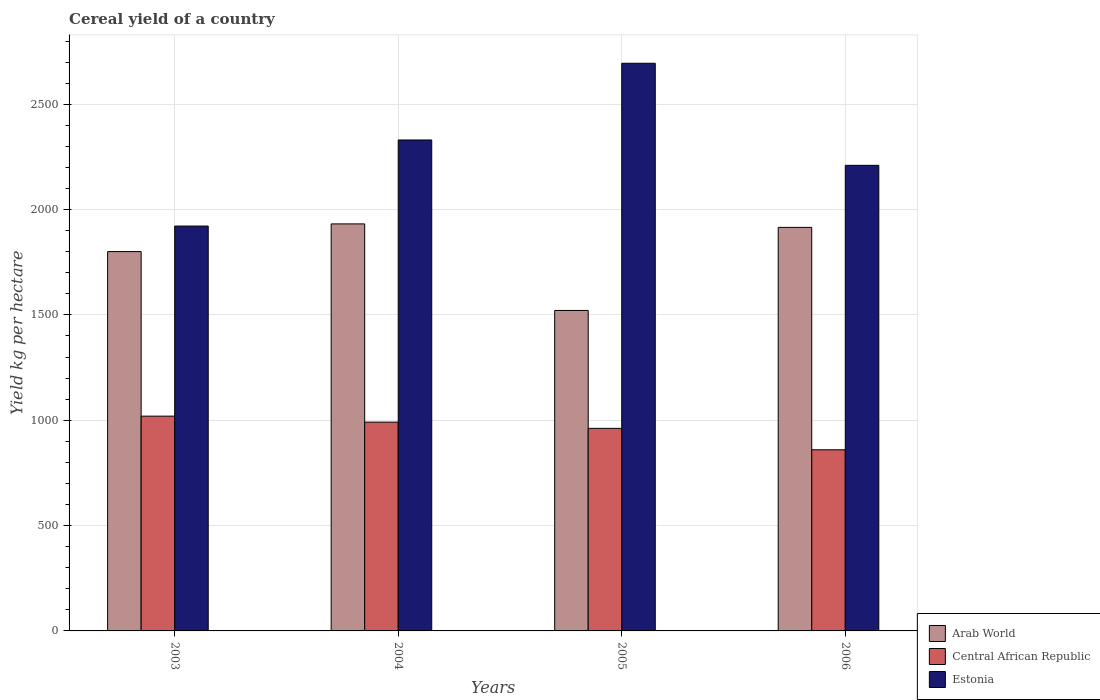How many groups of bars are there?
Your answer should be very brief. 4. Are the number of bars per tick equal to the number of legend labels?
Your answer should be compact. Yes. How many bars are there on the 4th tick from the left?
Provide a succinct answer. 3. How many bars are there on the 1st tick from the right?
Keep it short and to the point. 3. What is the label of the 3rd group of bars from the left?
Give a very brief answer. 2005. In how many cases, is the number of bars for a given year not equal to the number of legend labels?
Your answer should be very brief. 0. What is the total cereal yield in Estonia in 2003?
Offer a very short reply. 1921.7. Across all years, what is the maximum total cereal yield in Arab World?
Make the answer very short. 1931.94. Across all years, what is the minimum total cereal yield in Arab World?
Your answer should be very brief. 1521.1. What is the total total cereal yield in Central African Republic in the graph?
Ensure brevity in your answer.  3831.72. What is the difference between the total cereal yield in Estonia in 2004 and that in 2005?
Ensure brevity in your answer.  -364.14. What is the difference between the total cereal yield in Central African Republic in 2003 and the total cereal yield in Estonia in 2006?
Offer a terse response. -1190.48. What is the average total cereal yield in Arab World per year?
Your answer should be very brief. 1792.24. In the year 2005, what is the difference between the total cereal yield in Arab World and total cereal yield in Estonia?
Offer a terse response. -1173.3. What is the ratio of the total cereal yield in Arab World in 2004 to that in 2005?
Provide a succinct answer. 1.27. What is the difference between the highest and the second highest total cereal yield in Estonia?
Give a very brief answer. 364.14. What is the difference between the highest and the lowest total cereal yield in Central African Republic?
Give a very brief answer. 159.58. Is the sum of the total cereal yield in Estonia in 2004 and 2005 greater than the maximum total cereal yield in Arab World across all years?
Offer a very short reply. Yes. What does the 3rd bar from the left in 2004 represents?
Give a very brief answer. Estonia. What does the 3rd bar from the right in 2005 represents?
Give a very brief answer. Arab World. Is it the case that in every year, the sum of the total cereal yield in Central African Republic and total cereal yield in Arab World is greater than the total cereal yield in Estonia?
Your response must be concise. No. How many bars are there?
Offer a very short reply. 12. Are all the bars in the graph horizontal?
Your response must be concise. No. What is the difference between two consecutive major ticks on the Y-axis?
Offer a terse response. 500. Are the values on the major ticks of Y-axis written in scientific E-notation?
Provide a succinct answer. No. What is the title of the graph?
Make the answer very short. Cereal yield of a country. Does "Syrian Arab Republic" appear as one of the legend labels in the graph?
Keep it short and to the point. No. What is the label or title of the X-axis?
Make the answer very short. Years. What is the label or title of the Y-axis?
Keep it short and to the point. Yield kg per hectare. What is the Yield kg per hectare in Arab World in 2003?
Your answer should be compact. 1800.52. What is the Yield kg per hectare of Central African Republic in 2003?
Provide a succinct answer. 1019.42. What is the Yield kg per hectare in Estonia in 2003?
Your answer should be compact. 1921.7. What is the Yield kg per hectare in Arab World in 2004?
Give a very brief answer. 1931.94. What is the Yield kg per hectare in Central African Republic in 2004?
Your answer should be compact. 990.96. What is the Yield kg per hectare in Estonia in 2004?
Make the answer very short. 2330.26. What is the Yield kg per hectare of Arab World in 2005?
Your answer should be compact. 1521.1. What is the Yield kg per hectare in Central African Republic in 2005?
Ensure brevity in your answer.  961.5. What is the Yield kg per hectare in Estonia in 2005?
Provide a succinct answer. 2694.4. What is the Yield kg per hectare of Arab World in 2006?
Provide a succinct answer. 1915.38. What is the Yield kg per hectare of Central African Republic in 2006?
Provide a short and direct response. 859.84. What is the Yield kg per hectare of Estonia in 2006?
Ensure brevity in your answer.  2209.9. Across all years, what is the maximum Yield kg per hectare of Arab World?
Your response must be concise. 1931.94. Across all years, what is the maximum Yield kg per hectare in Central African Republic?
Ensure brevity in your answer.  1019.42. Across all years, what is the maximum Yield kg per hectare in Estonia?
Keep it short and to the point. 2694.4. Across all years, what is the minimum Yield kg per hectare in Arab World?
Your response must be concise. 1521.1. Across all years, what is the minimum Yield kg per hectare of Central African Republic?
Your answer should be very brief. 859.84. Across all years, what is the minimum Yield kg per hectare in Estonia?
Ensure brevity in your answer.  1921.7. What is the total Yield kg per hectare of Arab World in the graph?
Ensure brevity in your answer.  7168.94. What is the total Yield kg per hectare in Central African Republic in the graph?
Your answer should be very brief. 3831.72. What is the total Yield kg per hectare of Estonia in the graph?
Ensure brevity in your answer.  9156.25. What is the difference between the Yield kg per hectare in Arab World in 2003 and that in 2004?
Provide a succinct answer. -131.42. What is the difference between the Yield kg per hectare of Central African Republic in 2003 and that in 2004?
Your answer should be compact. 28.45. What is the difference between the Yield kg per hectare of Estonia in 2003 and that in 2004?
Make the answer very short. -408.56. What is the difference between the Yield kg per hectare in Arab World in 2003 and that in 2005?
Your answer should be compact. 279.42. What is the difference between the Yield kg per hectare of Central African Republic in 2003 and that in 2005?
Offer a terse response. 57.91. What is the difference between the Yield kg per hectare of Estonia in 2003 and that in 2005?
Provide a short and direct response. -772.7. What is the difference between the Yield kg per hectare of Arab World in 2003 and that in 2006?
Your response must be concise. -114.86. What is the difference between the Yield kg per hectare in Central African Republic in 2003 and that in 2006?
Give a very brief answer. 159.58. What is the difference between the Yield kg per hectare of Estonia in 2003 and that in 2006?
Your response must be concise. -288.2. What is the difference between the Yield kg per hectare of Arab World in 2004 and that in 2005?
Ensure brevity in your answer.  410.84. What is the difference between the Yield kg per hectare of Central African Republic in 2004 and that in 2005?
Keep it short and to the point. 29.46. What is the difference between the Yield kg per hectare of Estonia in 2004 and that in 2005?
Provide a short and direct response. -364.14. What is the difference between the Yield kg per hectare in Arab World in 2004 and that in 2006?
Your answer should be compact. 16.55. What is the difference between the Yield kg per hectare of Central African Republic in 2004 and that in 2006?
Provide a succinct answer. 131.12. What is the difference between the Yield kg per hectare of Estonia in 2004 and that in 2006?
Your response must be concise. 120.35. What is the difference between the Yield kg per hectare in Arab World in 2005 and that in 2006?
Offer a very short reply. -394.28. What is the difference between the Yield kg per hectare in Central African Republic in 2005 and that in 2006?
Make the answer very short. 101.67. What is the difference between the Yield kg per hectare of Estonia in 2005 and that in 2006?
Keep it short and to the point. 484.49. What is the difference between the Yield kg per hectare of Arab World in 2003 and the Yield kg per hectare of Central African Republic in 2004?
Make the answer very short. 809.56. What is the difference between the Yield kg per hectare of Arab World in 2003 and the Yield kg per hectare of Estonia in 2004?
Your answer should be compact. -529.73. What is the difference between the Yield kg per hectare of Central African Republic in 2003 and the Yield kg per hectare of Estonia in 2004?
Offer a terse response. -1310.84. What is the difference between the Yield kg per hectare of Arab World in 2003 and the Yield kg per hectare of Central African Republic in 2005?
Make the answer very short. 839.02. What is the difference between the Yield kg per hectare of Arab World in 2003 and the Yield kg per hectare of Estonia in 2005?
Make the answer very short. -893.87. What is the difference between the Yield kg per hectare of Central African Republic in 2003 and the Yield kg per hectare of Estonia in 2005?
Your answer should be very brief. -1674.98. What is the difference between the Yield kg per hectare in Arab World in 2003 and the Yield kg per hectare in Central African Republic in 2006?
Offer a terse response. 940.68. What is the difference between the Yield kg per hectare in Arab World in 2003 and the Yield kg per hectare in Estonia in 2006?
Your answer should be very brief. -409.38. What is the difference between the Yield kg per hectare in Central African Republic in 2003 and the Yield kg per hectare in Estonia in 2006?
Provide a succinct answer. -1190.48. What is the difference between the Yield kg per hectare in Arab World in 2004 and the Yield kg per hectare in Central African Republic in 2005?
Provide a short and direct response. 970.43. What is the difference between the Yield kg per hectare in Arab World in 2004 and the Yield kg per hectare in Estonia in 2005?
Your answer should be very brief. -762.46. What is the difference between the Yield kg per hectare in Central African Republic in 2004 and the Yield kg per hectare in Estonia in 2005?
Your response must be concise. -1703.43. What is the difference between the Yield kg per hectare in Arab World in 2004 and the Yield kg per hectare in Central African Republic in 2006?
Your response must be concise. 1072.1. What is the difference between the Yield kg per hectare in Arab World in 2004 and the Yield kg per hectare in Estonia in 2006?
Give a very brief answer. -277.96. What is the difference between the Yield kg per hectare of Central African Republic in 2004 and the Yield kg per hectare of Estonia in 2006?
Your response must be concise. -1218.94. What is the difference between the Yield kg per hectare in Arab World in 2005 and the Yield kg per hectare in Central African Republic in 2006?
Your response must be concise. 661.26. What is the difference between the Yield kg per hectare of Arab World in 2005 and the Yield kg per hectare of Estonia in 2006?
Give a very brief answer. -688.8. What is the difference between the Yield kg per hectare of Central African Republic in 2005 and the Yield kg per hectare of Estonia in 2006?
Offer a terse response. -1248.4. What is the average Yield kg per hectare of Arab World per year?
Give a very brief answer. 1792.24. What is the average Yield kg per hectare of Central African Republic per year?
Your answer should be very brief. 957.93. What is the average Yield kg per hectare of Estonia per year?
Keep it short and to the point. 2289.06. In the year 2003, what is the difference between the Yield kg per hectare of Arab World and Yield kg per hectare of Central African Republic?
Your answer should be compact. 781.1. In the year 2003, what is the difference between the Yield kg per hectare of Arab World and Yield kg per hectare of Estonia?
Ensure brevity in your answer.  -121.18. In the year 2003, what is the difference between the Yield kg per hectare of Central African Republic and Yield kg per hectare of Estonia?
Your response must be concise. -902.28. In the year 2004, what is the difference between the Yield kg per hectare of Arab World and Yield kg per hectare of Central African Republic?
Keep it short and to the point. 940.97. In the year 2004, what is the difference between the Yield kg per hectare of Arab World and Yield kg per hectare of Estonia?
Offer a terse response. -398.32. In the year 2004, what is the difference between the Yield kg per hectare in Central African Republic and Yield kg per hectare in Estonia?
Your response must be concise. -1339.29. In the year 2005, what is the difference between the Yield kg per hectare in Arab World and Yield kg per hectare in Central African Republic?
Your answer should be compact. 559.6. In the year 2005, what is the difference between the Yield kg per hectare in Arab World and Yield kg per hectare in Estonia?
Offer a terse response. -1173.3. In the year 2005, what is the difference between the Yield kg per hectare of Central African Republic and Yield kg per hectare of Estonia?
Your answer should be very brief. -1732.89. In the year 2006, what is the difference between the Yield kg per hectare of Arab World and Yield kg per hectare of Central African Republic?
Give a very brief answer. 1055.54. In the year 2006, what is the difference between the Yield kg per hectare of Arab World and Yield kg per hectare of Estonia?
Give a very brief answer. -294.52. In the year 2006, what is the difference between the Yield kg per hectare in Central African Republic and Yield kg per hectare in Estonia?
Keep it short and to the point. -1350.06. What is the ratio of the Yield kg per hectare in Arab World in 2003 to that in 2004?
Your answer should be compact. 0.93. What is the ratio of the Yield kg per hectare of Central African Republic in 2003 to that in 2004?
Give a very brief answer. 1.03. What is the ratio of the Yield kg per hectare in Estonia in 2003 to that in 2004?
Your answer should be compact. 0.82. What is the ratio of the Yield kg per hectare of Arab World in 2003 to that in 2005?
Your answer should be very brief. 1.18. What is the ratio of the Yield kg per hectare of Central African Republic in 2003 to that in 2005?
Make the answer very short. 1.06. What is the ratio of the Yield kg per hectare in Estonia in 2003 to that in 2005?
Make the answer very short. 0.71. What is the ratio of the Yield kg per hectare of Arab World in 2003 to that in 2006?
Your answer should be compact. 0.94. What is the ratio of the Yield kg per hectare in Central African Republic in 2003 to that in 2006?
Provide a succinct answer. 1.19. What is the ratio of the Yield kg per hectare in Estonia in 2003 to that in 2006?
Your answer should be very brief. 0.87. What is the ratio of the Yield kg per hectare of Arab World in 2004 to that in 2005?
Your response must be concise. 1.27. What is the ratio of the Yield kg per hectare of Central African Republic in 2004 to that in 2005?
Your answer should be very brief. 1.03. What is the ratio of the Yield kg per hectare of Estonia in 2004 to that in 2005?
Give a very brief answer. 0.86. What is the ratio of the Yield kg per hectare of Arab World in 2004 to that in 2006?
Make the answer very short. 1.01. What is the ratio of the Yield kg per hectare of Central African Republic in 2004 to that in 2006?
Offer a very short reply. 1.15. What is the ratio of the Yield kg per hectare in Estonia in 2004 to that in 2006?
Your answer should be compact. 1.05. What is the ratio of the Yield kg per hectare of Arab World in 2005 to that in 2006?
Keep it short and to the point. 0.79. What is the ratio of the Yield kg per hectare of Central African Republic in 2005 to that in 2006?
Keep it short and to the point. 1.12. What is the ratio of the Yield kg per hectare in Estonia in 2005 to that in 2006?
Your answer should be very brief. 1.22. What is the difference between the highest and the second highest Yield kg per hectare in Arab World?
Your answer should be compact. 16.55. What is the difference between the highest and the second highest Yield kg per hectare in Central African Republic?
Ensure brevity in your answer.  28.45. What is the difference between the highest and the second highest Yield kg per hectare in Estonia?
Your response must be concise. 364.14. What is the difference between the highest and the lowest Yield kg per hectare of Arab World?
Make the answer very short. 410.84. What is the difference between the highest and the lowest Yield kg per hectare in Central African Republic?
Offer a very short reply. 159.58. What is the difference between the highest and the lowest Yield kg per hectare of Estonia?
Your answer should be compact. 772.7. 